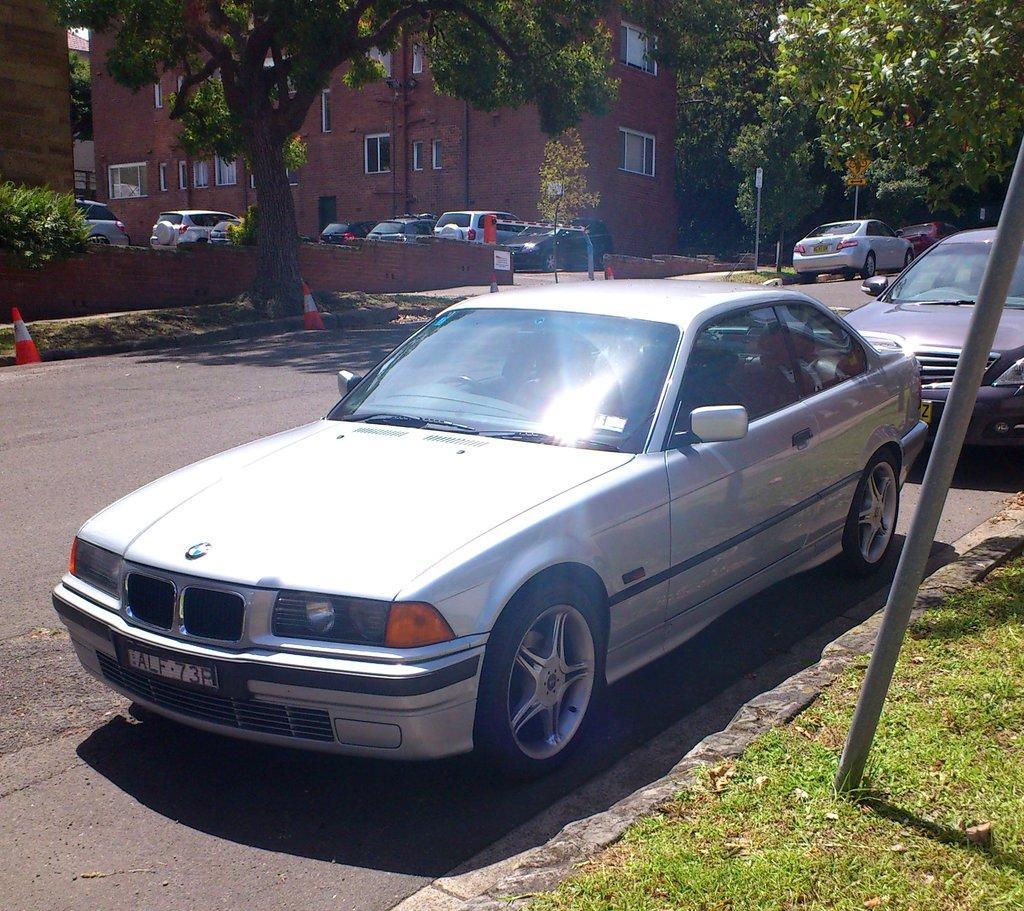Please provide a concise description of this image. In this image we can see few buildings. There are few road safety cones on the road. There are few vehicles in the image. We can see few trees and plants in the image. There is a grassy land at the bottom of the image. 